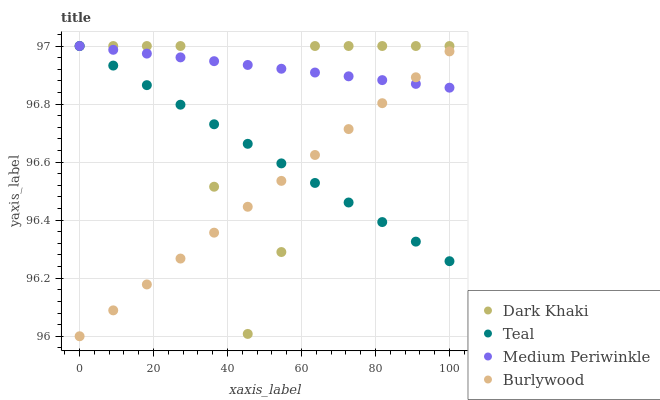Does Burlywood have the minimum area under the curve?
Answer yes or no. Yes. Does Medium Periwinkle have the maximum area under the curve?
Answer yes or no. Yes. Does Medium Periwinkle have the minimum area under the curve?
Answer yes or no. No. Does Burlywood have the maximum area under the curve?
Answer yes or no. No. Is Burlywood the smoothest?
Answer yes or no. Yes. Is Dark Khaki the roughest?
Answer yes or no. Yes. Is Medium Periwinkle the smoothest?
Answer yes or no. No. Is Medium Periwinkle the roughest?
Answer yes or no. No. Does Burlywood have the lowest value?
Answer yes or no. Yes. Does Medium Periwinkle have the lowest value?
Answer yes or no. No. Does Teal have the highest value?
Answer yes or no. Yes. Does Burlywood have the highest value?
Answer yes or no. No. Does Teal intersect Medium Periwinkle?
Answer yes or no. Yes. Is Teal less than Medium Periwinkle?
Answer yes or no. No. Is Teal greater than Medium Periwinkle?
Answer yes or no. No. 